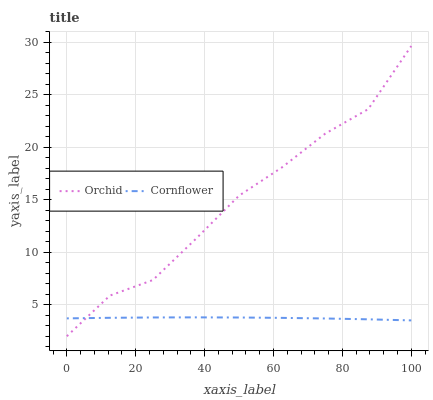Does Cornflower have the minimum area under the curve?
Answer yes or no. Yes. Does Orchid have the maximum area under the curve?
Answer yes or no. Yes. Does Orchid have the minimum area under the curve?
Answer yes or no. No. Is Cornflower the smoothest?
Answer yes or no. Yes. Is Orchid the roughest?
Answer yes or no. Yes. Is Orchid the smoothest?
Answer yes or no. No. Does Orchid have the highest value?
Answer yes or no. Yes. Does Cornflower intersect Orchid?
Answer yes or no. Yes. Is Cornflower less than Orchid?
Answer yes or no. No. Is Cornflower greater than Orchid?
Answer yes or no. No. 